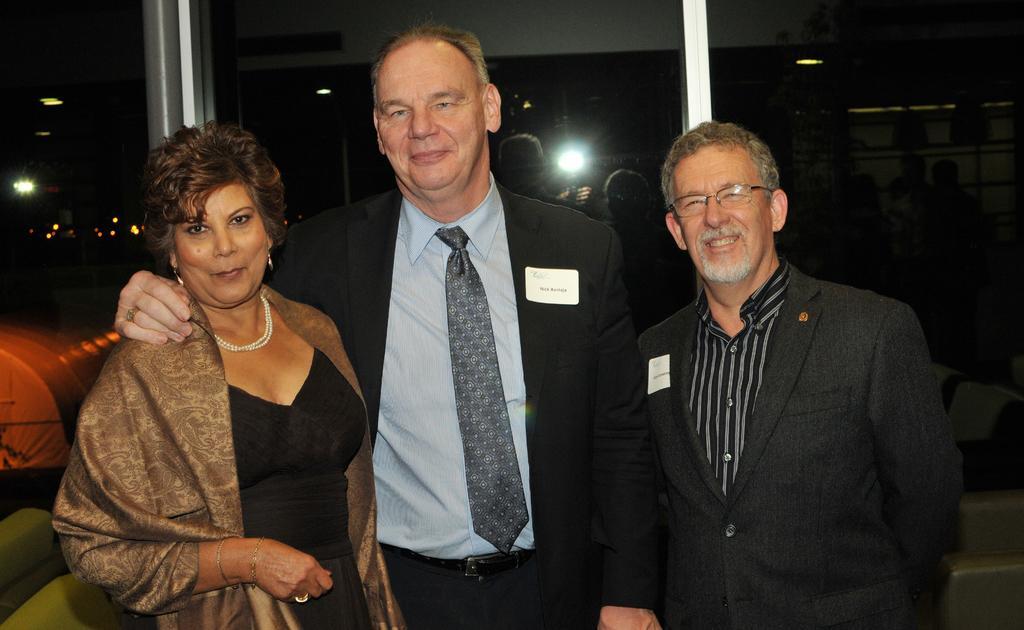Can you describe this image briefly? In this picture we can see three people and they are smiling and in the background we can see few people, lights and few objects. 